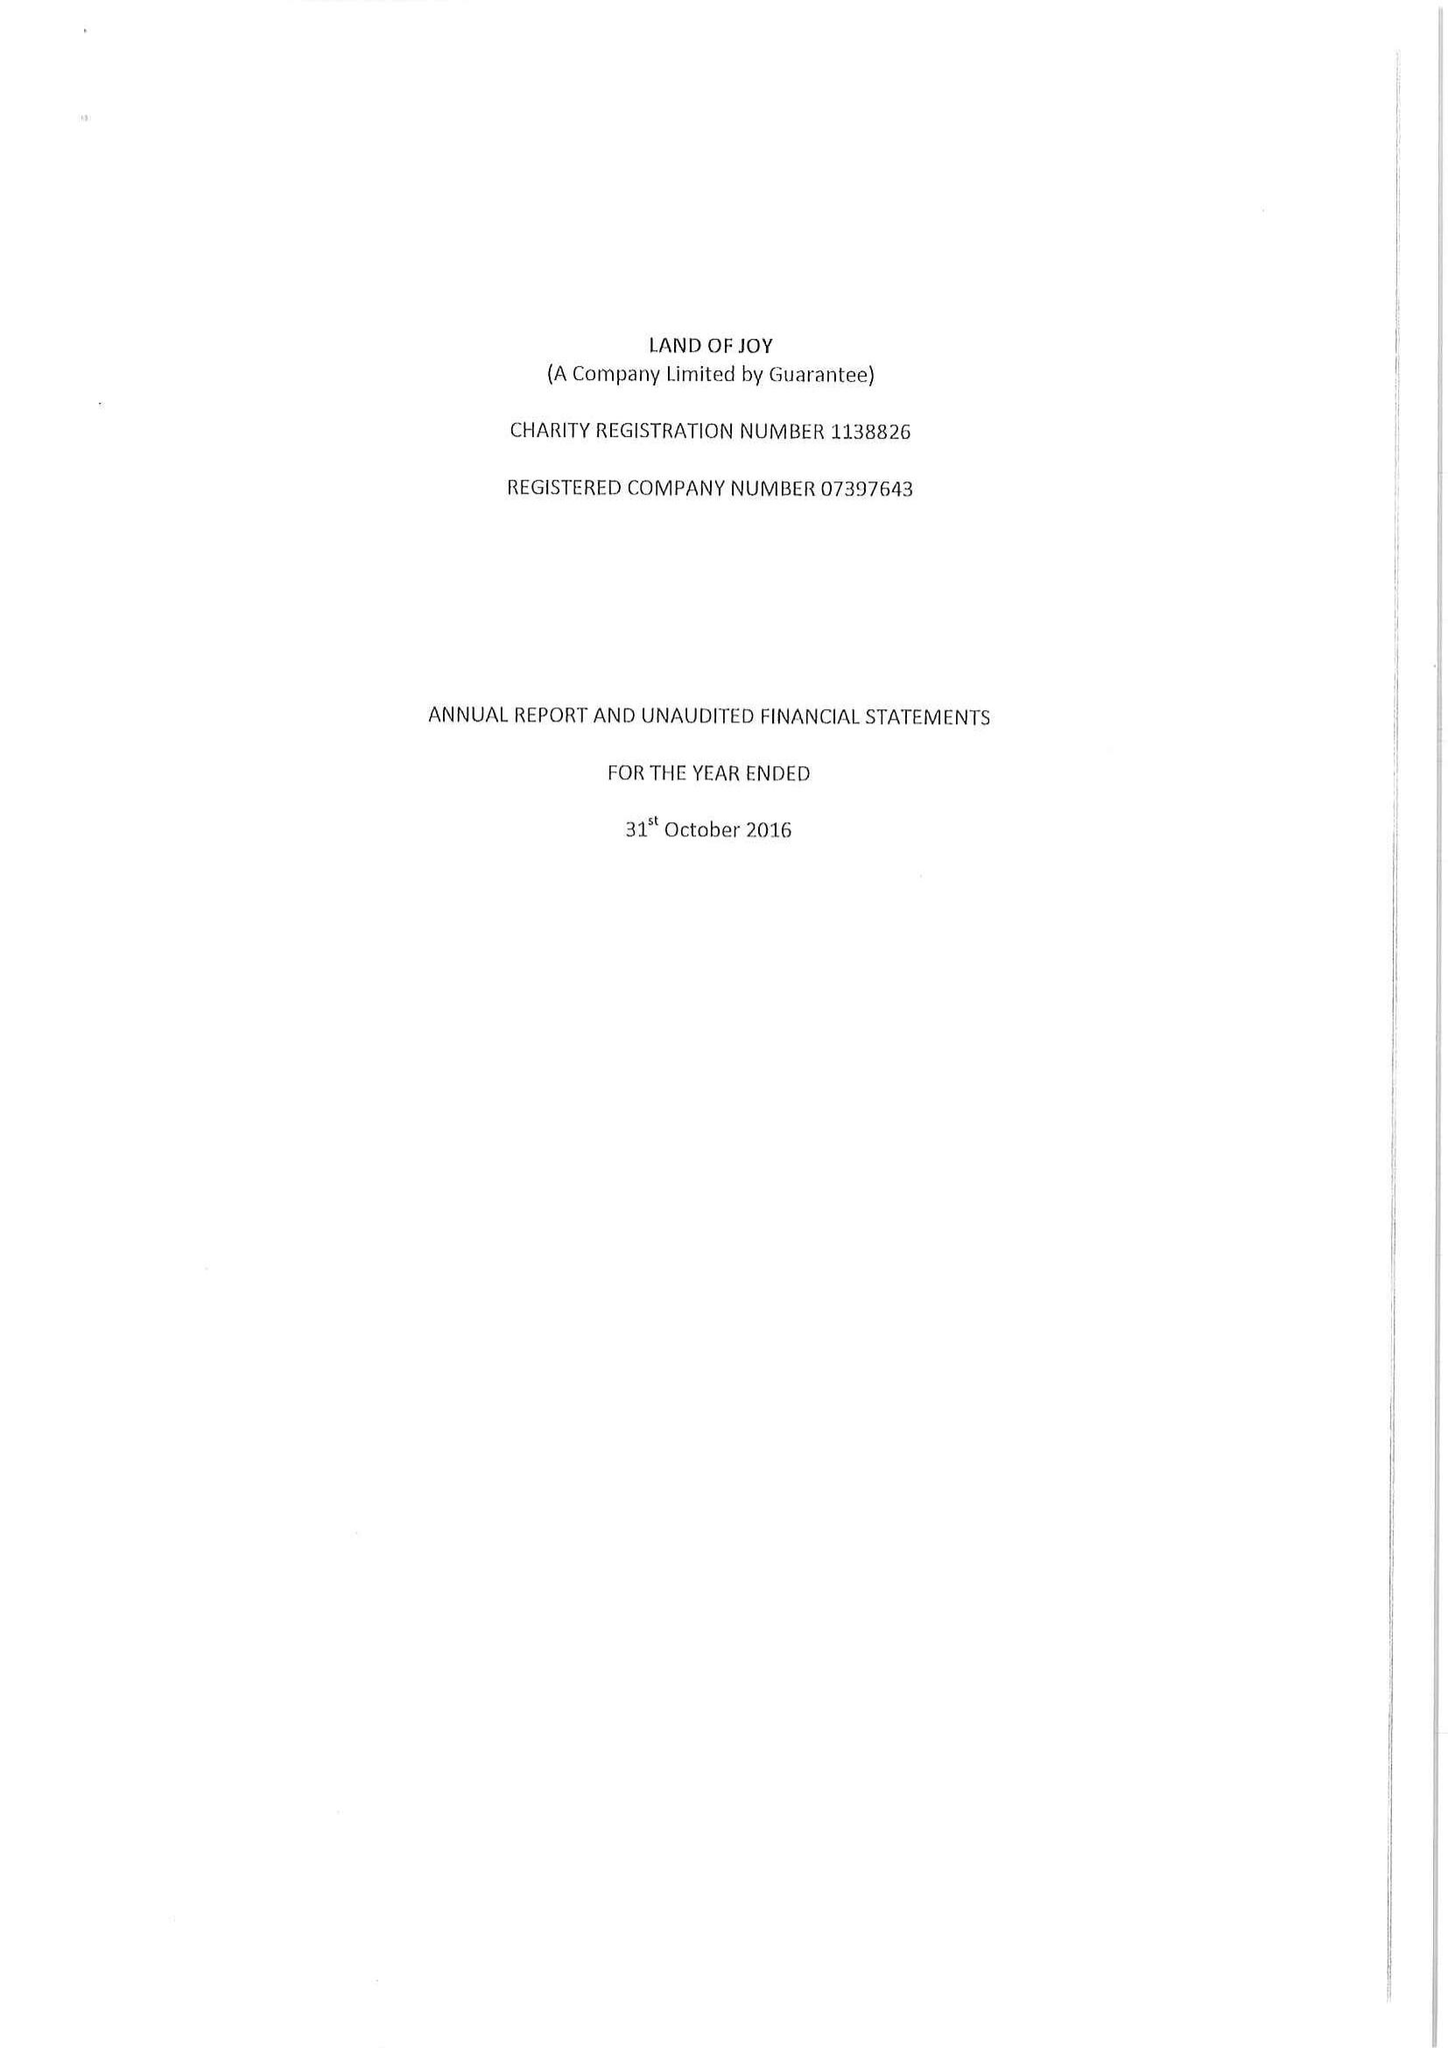What is the value for the report_date?
Answer the question using a single word or phrase. 2016-10-31 